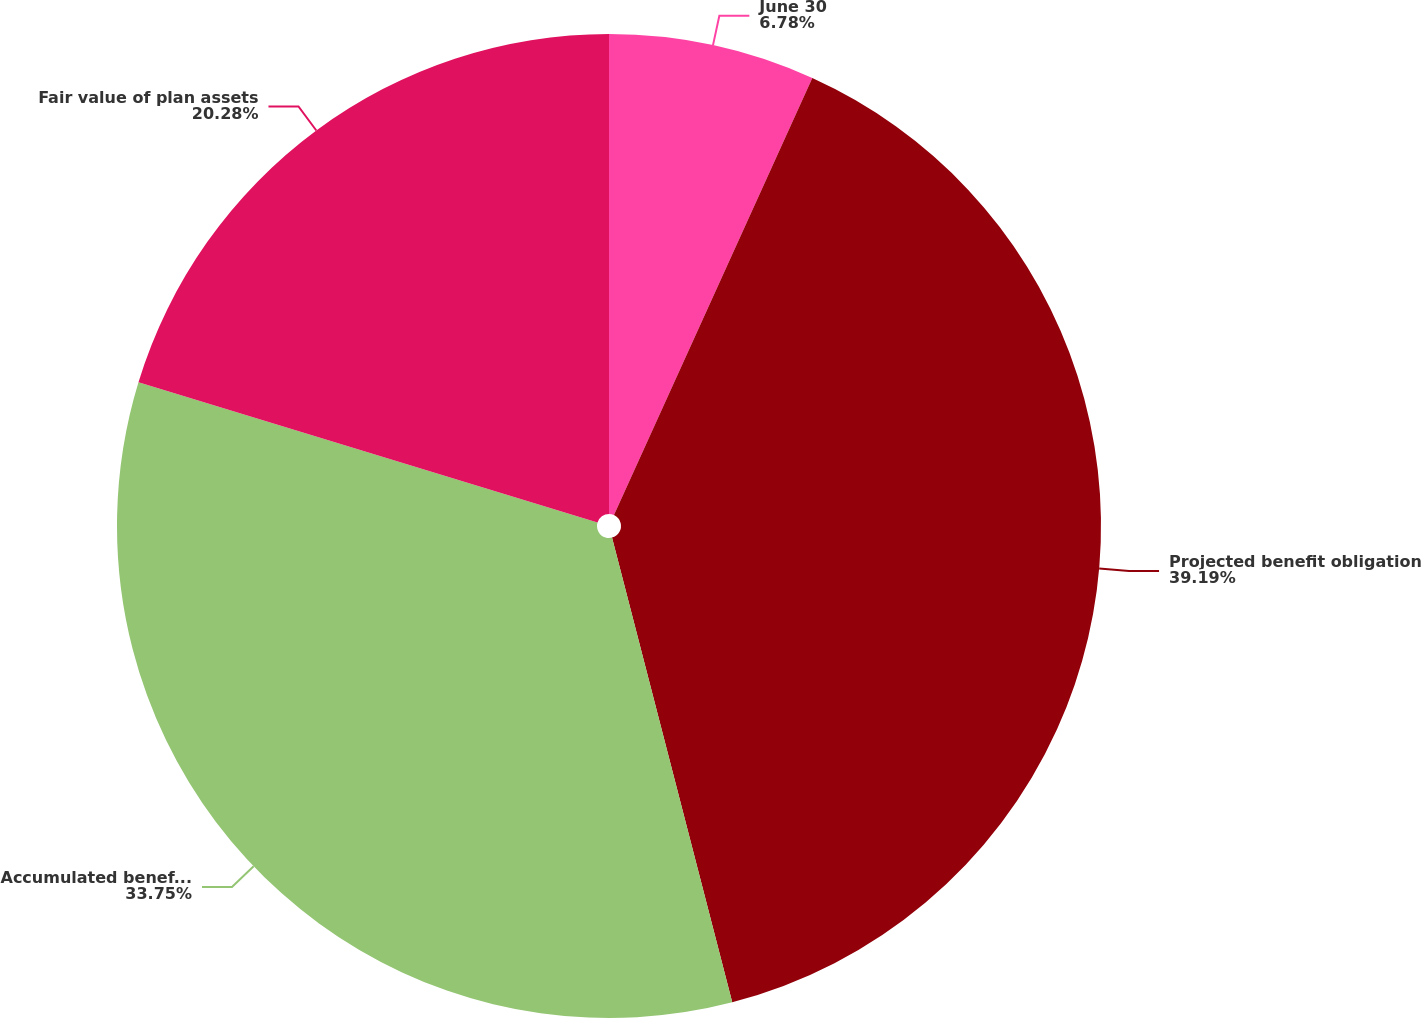Convert chart. <chart><loc_0><loc_0><loc_500><loc_500><pie_chart><fcel>June 30<fcel>Projected benefit obligation<fcel>Accumulated benefit obligation<fcel>Fair value of plan assets<nl><fcel>6.78%<fcel>39.19%<fcel>33.75%<fcel>20.28%<nl></chart> 